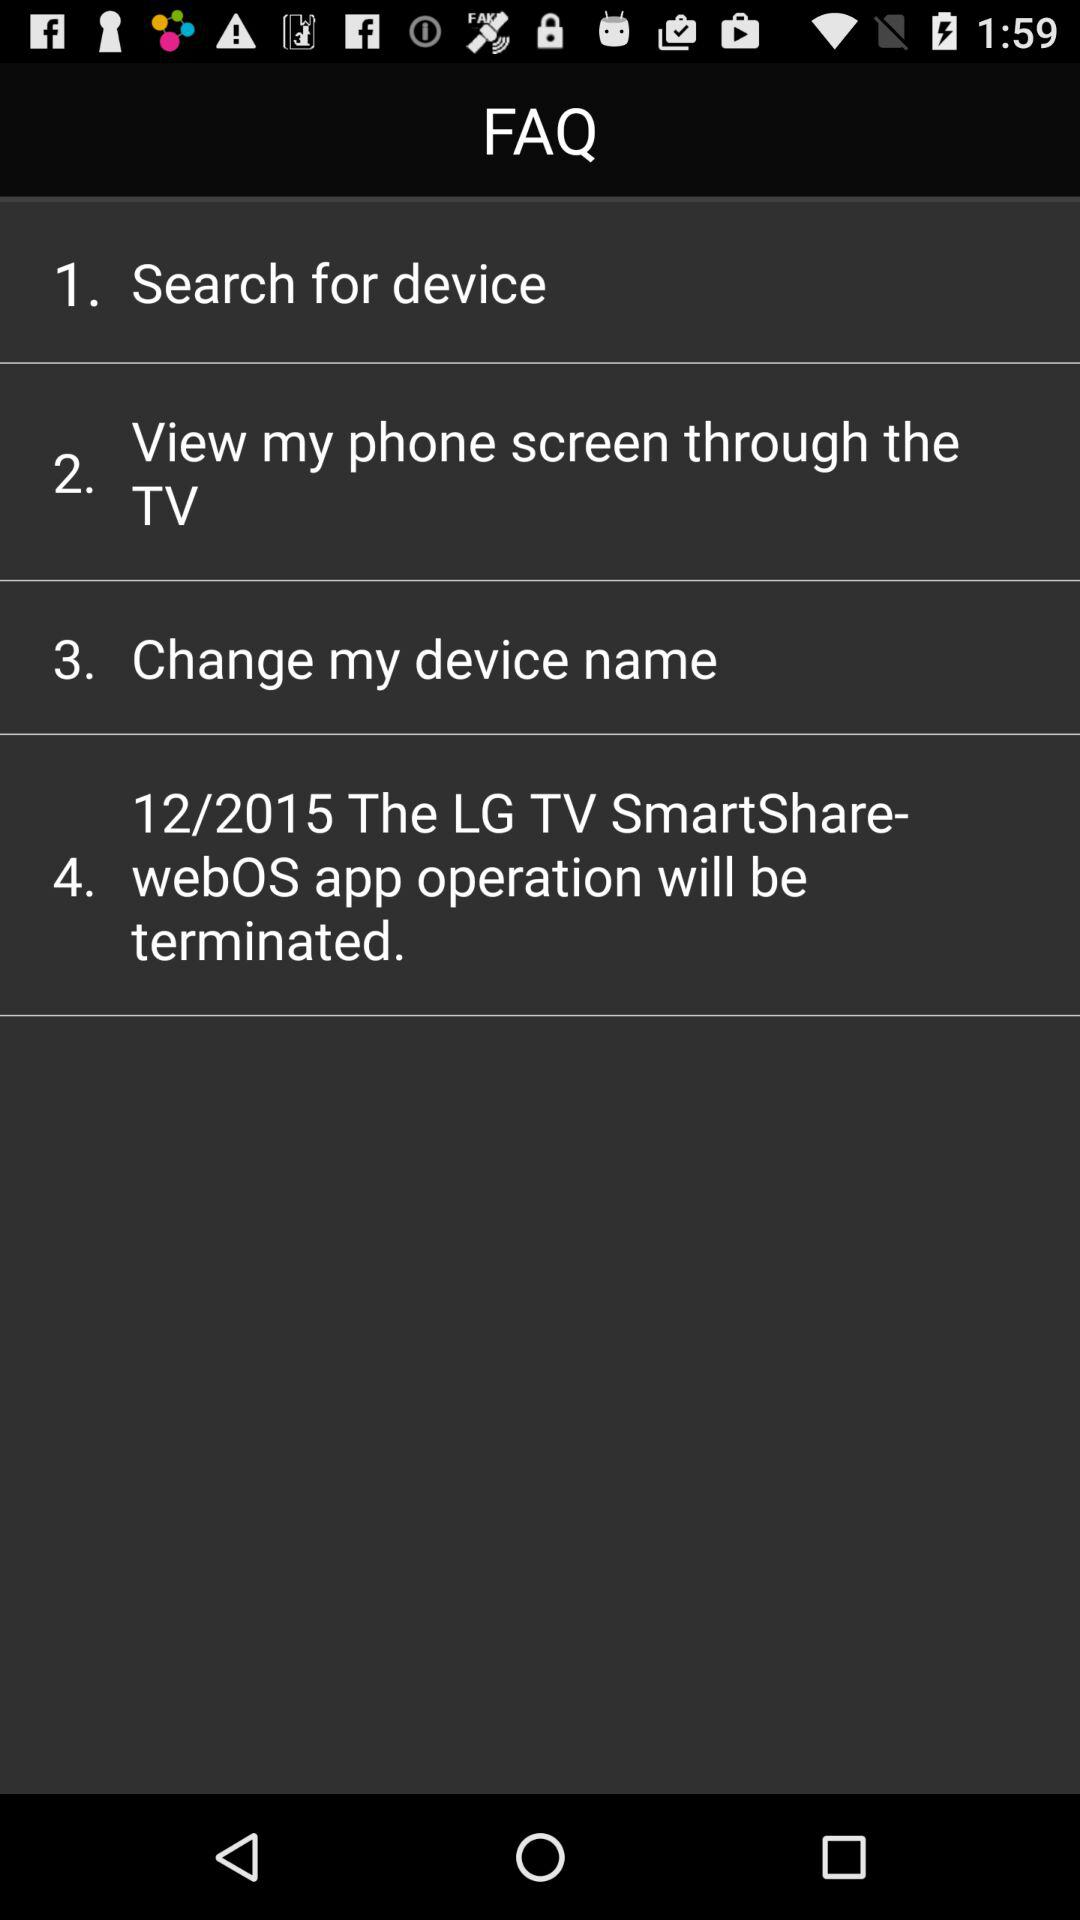What date is shown on the screen?
When the provided information is insufficient, respond with <no answer>. <no answer> 